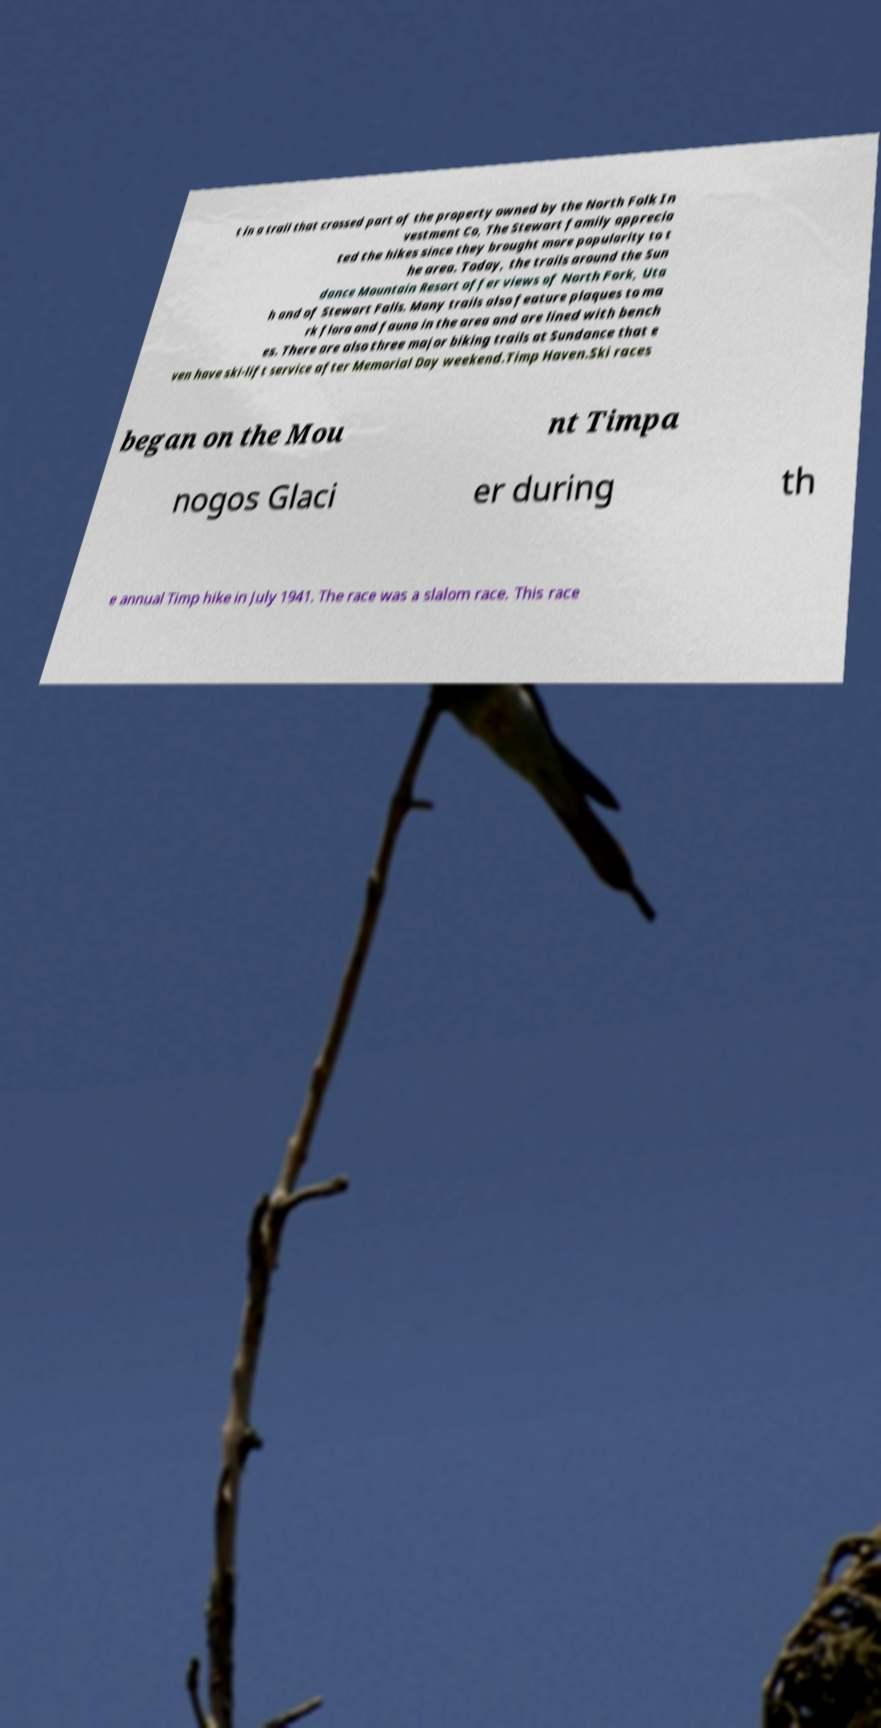Please identify and transcribe the text found in this image. t in a trail that crossed part of the property owned by the North Folk In vestment Co, The Stewart family apprecia ted the hikes since they brought more popularity to t he area. Today, the trails around the Sun dance Mountain Resort offer views of North Fork, Uta h and of Stewart Falls. Many trails also feature plaques to ma rk flora and fauna in the area and are lined with bench es. There are also three major biking trails at Sundance that e ven have ski-lift service after Memorial Day weekend.Timp Haven.Ski races began on the Mou nt Timpa nogos Glaci er during th e annual Timp hike in July 1941. The race was a slalom race. This race 